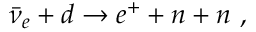Convert formula to latex. <formula><loc_0><loc_0><loc_500><loc_500>\bar { \nu } _ { e } + d \rightarrow e ^ { + } + n + n ,</formula> 